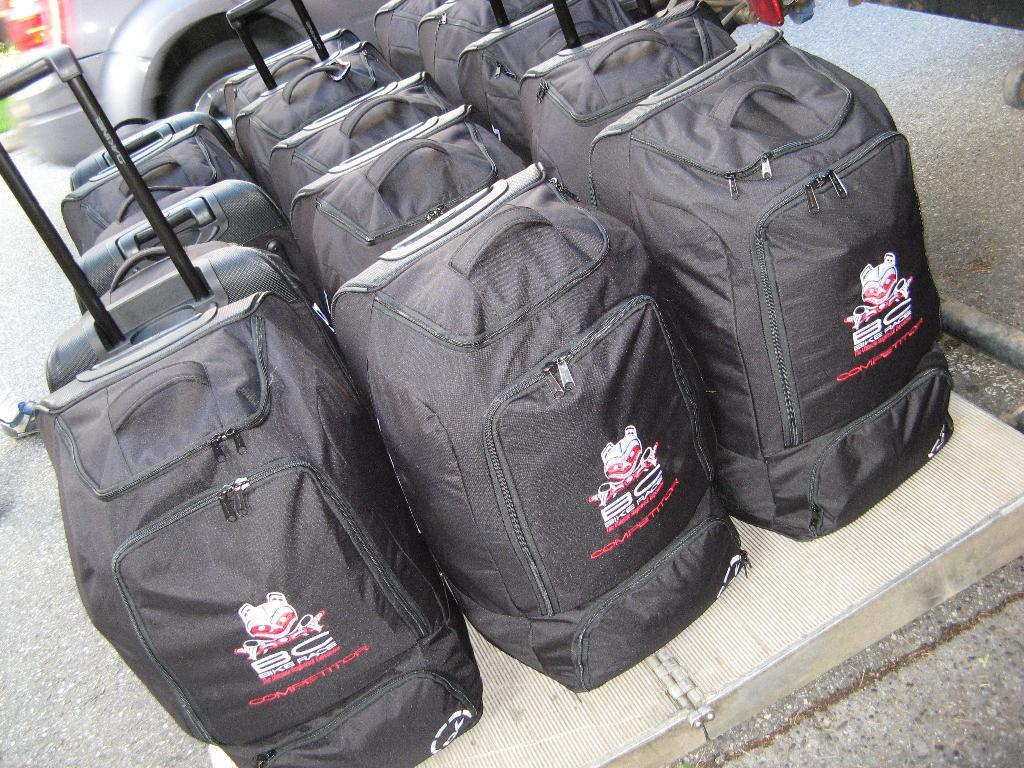What type of luggage bags are visible in the image? There are black luggage bags in the image. How are the luggage bags emphasized or distinguished? The luggage bags are highlighted in the image. What else can be seen in the image besides the luggage bags? There is a vehicle visible on the backside of the luggage bags. What type of branch is growing out of the luggage bags in the image? There is no branch growing out of the luggage bags in the image. What kind of lunch is being served on the luggage bags in the image? There is no lunch being served on the luggage bags in the image. 